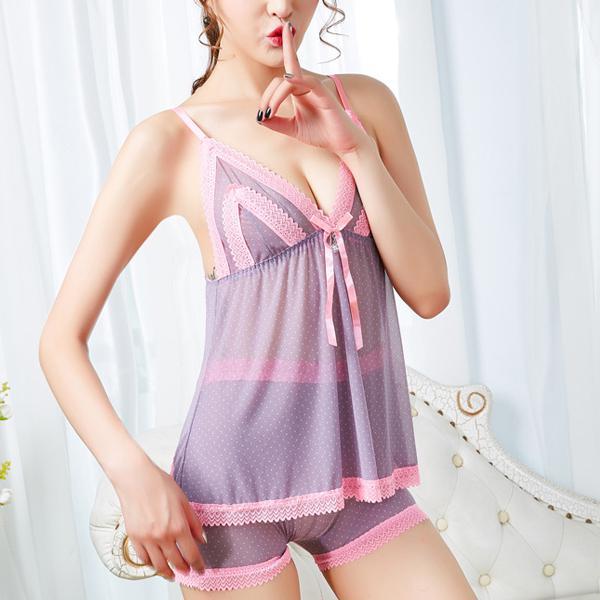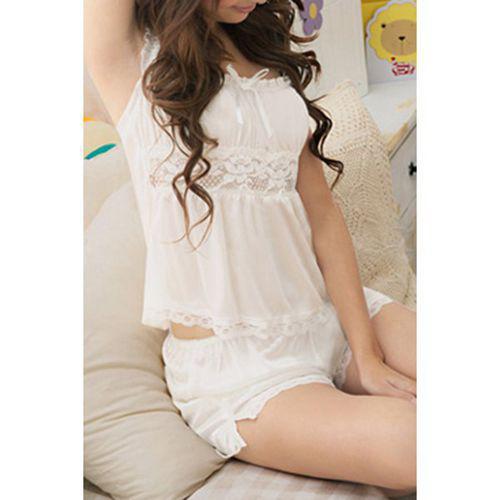The first image is the image on the left, the second image is the image on the right. Considering the images on both sides, is "One model is blonde and wears something made of satiny, shiny material, while the other model wears shorts with a short-sleeved top that doesn't bare her midriff." valid? Answer yes or no. No. The first image is the image on the left, the second image is the image on the right. Assess this claim about the two images: "A pajama set is a pair of short pants paired with a t-shirt top with short sleeves and design printed on the front.". Correct or not? Answer yes or no. No. 